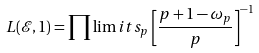<formula> <loc_0><loc_0><loc_500><loc_500>L ( \mathcal { E } , 1 ) = \prod \lim i t s _ { p } \left [ \frac { p + 1 - \omega _ { p } } { p } \right ] ^ { - 1 }</formula> 